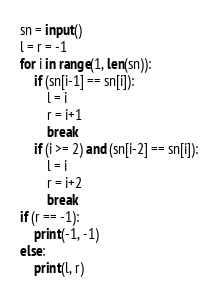<code> <loc_0><loc_0><loc_500><loc_500><_Python_>sn = input()
l = r = -1
for i in range(1, len(sn)):
    if (sn[i-1] == sn[i]):
        l = i
        r = i+1
        break
    if (i >= 2) and (sn[i-2] == sn[i]):
        l = i
        r = i+2
        break
if (r == -1):
    print(-1, -1)
else:
    print(l, r)</code> 